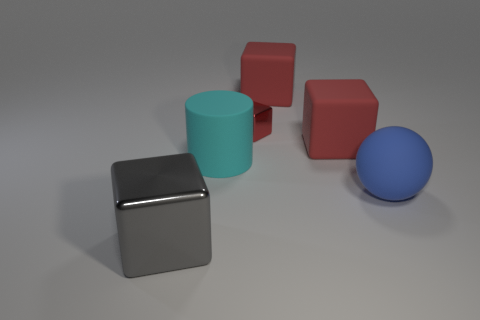Subtract all red cubes. How many were subtracted if there are1red cubes left? 2 Subtract all purple cylinders. How many red cubes are left? 3 Add 1 large gray shiny blocks. How many objects exist? 7 Subtract all cylinders. How many objects are left? 5 Add 6 big blue rubber balls. How many big blue rubber balls exist? 7 Subtract 0 brown blocks. How many objects are left? 6 Subtract all tiny purple shiny objects. Subtract all red things. How many objects are left? 3 Add 1 cyan matte cylinders. How many cyan matte cylinders are left? 2 